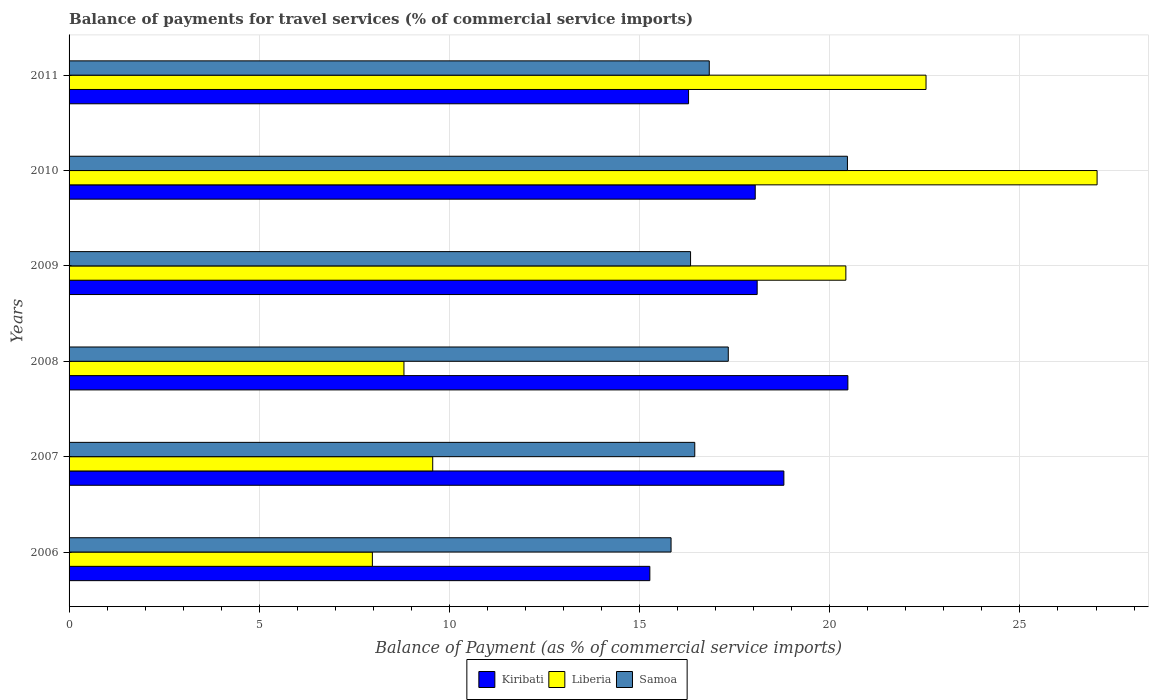Are the number of bars per tick equal to the number of legend labels?
Your response must be concise. Yes. Are the number of bars on each tick of the Y-axis equal?
Give a very brief answer. Yes. How many bars are there on the 5th tick from the bottom?
Make the answer very short. 3. What is the label of the 3rd group of bars from the top?
Provide a short and direct response. 2009. What is the balance of payments for travel services in Liberia in 2007?
Make the answer very short. 9.56. Across all years, what is the maximum balance of payments for travel services in Samoa?
Offer a terse response. 20.46. Across all years, what is the minimum balance of payments for travel services in Kiribati?
Give a very brief answer. 15.27. In which year was the balance of payments for travel services in Liberia maximum?
Your answer should be compact. 2010. What is the total balance of payments for travel services in Samoa in the graph?
Keep it short and to the point. 103.25. What is the difference between the balance of payments for travel services in Kiribati in 2008 and that in 2009?
Give a very brief answer. 2.38. What is the difference between the balance of payments for travel services in Samoa in 2009 and the balance of payments for travel services in Liberia in 2008?
Provide a short and direct response. 7.54. What is the average balance of payments for travel services in Samoa per year?
Ensure brevity in your answer.  17.21. In the year 2008, what is the difference between the balance of payments for travel services in Liberia and balance of payments for travel services in Samoa?
Your answer should be very brief. -8.53. What is the ratio of the balance of payments for travel services in Samoa in 2009 to that in 2010?
Your response must be concise. 0.8. Is the balance of payments for travel services in Kiribati in 2007 less than that in 2010?
Offer a terse response. No. What is the difference between the highest and the second highest balance of payments for travel services in Kiribati?
Ensure brevity in your answer.  1.68. What is the difference between the highest and the lowest balance of payments for travel services in Kiribati?
Provide a short and direct response. 5.21. Is the sum of the balance of payments for travel services in Liberia in 2007 and 2009 greater than the maximum balance of payments for travel services in Kiribati across all years?
Your answer should be very brief. Yes. What does the 2nd bar from the top in 2008 represents?
Ensure brevity in your answer.  Liberia. What does the 2nd bar from the bottom in 2010 represents?
Offer a very short reply. Liberia. How many bars are there?
Provide a succinct answer. 18. Are all the bars in the graph horizontal?
Keep it short and to the point. Yes. How many years are there in the graph?
Your answer should be compact. 6. What is the difference between two consecutive major ticks on the X-axis?
Give a very brief answer. 5. Are the values on the major ticks of X-axis written in scientific E-notation?
Your answer should be compact. No. What is the title of the graph?
Your answer should be very brief. Balance of payments for travel services (% of commercial service imports). Does "Argentina" appear as one of the legend labels in the graph?
Keep it short and to the point. No. What is the label or title of the X-axis?
Provide a short and direct response. Balance of Payment (as % of commercial service imports). What is the Balance of Payment (as % of commercial service imports) in Kiribati in 2006?
Give a very brief answer. 15.27. What is the Balance of Payment (as % of commercial service imports) in Liberia in 2006?
Your response must be concise. 7.97. What is the Balance of Payment (as % of commercial service imports) in Samoa in 2006?
Offer a very short reply. 15.83. What is the Balance of Payment (as % of commercial service imports) of Kiribati in 2007?
Provide a succinct answer. 18.79. What is the Balance of Payment (as % of commercial service imports) of Liberia in 2007?
Offer a terse response. 9.56. What is the Balance of Payment (as % of commercial service imports) in Samoa in 2007?
Ensure brevity in your answer.  16.45. What is the Balance of Payment (as % of commercial service imports) of Kiribati in 2008?
Offer a terse response. 20.48. What is the Balance of Payment (as % of commercial service imports) in Liberia in 2008?
Your response must be concise. 8.8. What is the Balance of Payment (as % of commercial service imports) of Samoa in 2008?
Offer a terse response. 17.33. What is the Balance of Payment (as % of commercial service imports) of Kiribati in 2009?
Offer a very short reply. 18.09. What is the Balance of Payment (as % of commercial service imports) of Liberia in 2009?
Offer a terse response. 20.42. What is the Balance of Payment (as % of commercial service imports) of Samoa in 2009?
Keep it short and to the point. 16.34. What is the Balance of Payment (as % of commercial service imports) of Kiribati in 2010?
Provide a short and direct response. 18.04. What is the Balance of Payment (as % of commercial service imports) of Liberia in 2010?
Give a very brief answer. 27.03. What is the Balance of Payment (as % of commercial service imports) of Samoa in 2010?
Make the answer very short. 20.46. What is the Balance of Payment (as % of commercial service imports) in Kiribati in 2011?
Provide a short and direct response. 16.29. What is the Balance of Payment (as % of commercial service imports) of Liberia in 2011?
Offer a very short reply. 22.53. What is the Balance of Payment (as % of commercial service imports) of Samoa in 2011?
Your answer should be compact. 16.83. Across all years, what is the maximum Balance of Payment (as % of commercial service imports) in Kiribati?
Your answer should be very brief. 20.48. Across all years, what is the maximum Balance of Payment (as % of commercial service imports) in Liberia?
Offer a very short reply. 27.03. Across all years, what is the maximum Balance of Payment (as % of commercial service imports) of Samoa?
Make the answer very short. 20.46. Across all years, what is the minimum Balance of Payment (as % of commercial service imports) in Kiribati?
Ensure brevity in your answer.  15.27. Across all years, what is the minimum Balance of Payment (as % of commercial service imports) of Liberia?
Provide a short and direct response. 7.97. Across all years, what is the minimum Balance of Payment (as % of commercial service imports) in Samoa?
Offer a very short reply. 15.83. What is the total Balance of Payment (as % of commercial service imports) of Kiribati in the graph?
Provide a short and direct response. 106.96. What is the total Balance of Payment (as % of commercial service imports) of Liberia in the graph?
Provide a short and direct response. 96.32. What is the total Balance of Payment (as % of commercial service imports) of Samoa in the graph?
Your response must be concise. 103.25. What is the difference between the Balance of Payment (as % of commercial service imports) of Kiribati in 2006 and that in 2007?
Ensure brevity in your answer.  -3.52. What is the difference between the Balance of Payment (as % of commercial service imports) in Liberia in 2006 and that in 2007?
Ensure brevity in your answer.  -1.59. What is the difference between the Balance of Payment (as % of commercial service imports) of Samoa in 2006 and that in 2007?
Give a very brief answer. -0.62. What is the difference between the Balance of Payment (as % of commercial service imports) of Kiribati in 2006 and that in 2008?
Your answer should be compact. -5.21. What is the difference between the Balance of Payment (as % of commercial service imports) of Liberia in 2006 and that in 2008?
Your response must be concise. -0.83. What is the difference between the Balance of Payment (as % of commercial service imports) in Samoa in 2006 and that in 2008?
Offer a very short reply. -1.5. What is the difference between the Balance of Payment (as % of commercial service imports) of Kiribati in 2006 and that in 2009?
Offer a very short reply. -2.82. What is the difference between the Balance of Payment (as % of commercial service imports) of Liberia in 2006 and that in 2009?
Your response must be concise. -12.45. What is the difference between the Balance of Payment (as % of commercial service imports) in Samoa in 2006 and that in 2009?
Offer a very short reply. -0.51. What is the difference between the Balance of Payment (as % of commercial service imports) of Kiribati in 2006 and that in 2010?
Provide a succinct answer. -2.77. What is the difference between the Balance of Payment (as % of commercial service imports) in Liberia in 2006 and that in 2010?
Provide a succinct answer. -19.05. What is the difference between the Balance of Payment (as % of commercial service imports) of Samoa in 2006 and that in 2010?
Ensure brevity in your answer.  -4.64. What is the difference between the Balance of Payment (as % of commercial service imports) of Kiribati in 2006 and that in 2011?
Offer a terse response. -1.02. What is the difference between the Balance of Payment (as % of commercial service imports) in Liberia in 2006 and that in 2011?
Your answer should be very brief. -14.56. What is the difference between the Balance of Payment (as % of commercial service imports) in Samoa in 2006 and that in 2011?
Your response must be concise. -1. What is the difference between the Balance of Payment (as % of commercial service imports) of Kiribati in 2007 and that in 2008?
Ensure brevity in your answer.  -1.68. What is the difference between the Balance of Payment (as % of commercial service imports) in Liberia in 2007 and that in 2008?
Provide a succinct answer. 0.76. What is the difference between the Balance of Payment (as % of commercial service imports) in Samoa in 2007 and that in 2008?
Provide a succinct answer. -0.88. What is the difference between the Balance of Payment (as % of commercial service imports) of Kiribati in 2007 and that in 2009?
Your response must be concise. 0.7. What is the difference between the Balance of Payment (as % of commercial service imports) of Liberia in 2007 and that in 2009?
Make the answer very short. -10.86. What is the difference between the Balance of Payment (as % of commercial service imports) of Samoa in 2007 and that in 2009?
Your response must be concise. 0.11. What is the difference between the Balance of Payment (as % of commercial service imports) of Kiribati in 2007 and that in 2010?
Offer a very short reply. 0.75. What is the difference between the Balance of Payment (as % of commercial service imports) of Liberia in 2007 and that in 2010?
Provide a short and direct response. -17.47. What is the difference between the Balance of Payment (as % of commercial service imports) in Samoa in 2007 and that in 2010?
Keep it short and to the point. -4.01. What is the difference between the Balance of Payment (as % of commercial service imports) of Kiribati in 2007 and that in 2011?
Offer a very short reply. 2.51. What is the difference between the Balance of Payment (as % of commercial service imports) in Liberia in 2007 and that in 2011?
Offer a terse response. -12.97. What is the difference between the Balance of Payment (as % of commercial service imports) in Samoa in 2007 and that in 2011?
Make the answer very short. -0.38. What is the difference between the Balance of Payment (as % of commercial service imports) of Kiribati in 2008 and that in 2009?
Provide a short and direct response. 2.38. What is the difference between the Balance of Payment (as % of commercial service imports) of Liberia in 2008 and that in 2009?
Offer a very short reply. -11.62. What is the difference between the Balance of Payment (as % of commercial service imports) in Samoa in 2008 and that in 2009?
Provide a succinct answer. 0.99. What is the difference between the Balance of Payment (as % of commercial service imports) in Kiribati in 2008 and that in 2010?
Your answer should be compact. 2.44. What is the difference between the Balance of Payment (as % of commercial service imports) in Liberia in 2008 and that in 2010?
Your answer should be very brief. -18.22. What is the difference between the Balance of Payment (as % of commercial service imports) in Samoa in 2008 and that in 2010?
Offer a very short reply. -3.13. What is the difference between the Balance of Payment (as % of commercial service imports) of Kiribati in 2008 and that in 2011?
Offer a terse response. 4.19. What is the difference between the Balance of Payment (as % of commercial service imports) of Liberia in 2008 and that in 2011?
Ensure brevity in your answer.  -13.73. What is the difference between the Balance of Payment (as % of commercial service imports) in Kiribati in 2009 and that in 2010?
Provide a succinct answer. 0.05. What is the difference between the Balance of Payment (as % of commercial service imports) in Liberia in 2009 and that in 2010?
Your answer should be compact. -6.61. What is the difference between the Balance of Payment (as % of commercial service imports) of Samoa in 2009 and that in 2010?
Ensure brevity in your answer.  -4.12. What is the difference between the Balance of Payment (as % of commercial service imports) of Kiribati in 2009 and that in 2011?
Offer a terse response. 1.8. What is the difference between the Balance of Payment (as % of commercial service imports) in Liberia in 2009 and that in 2011?
Your answer should be compact. -2.11. What is the difference between the Balance of Payment (as % of commercial service imports) of Samoa in 2009 and that in 2011?
Your answer should be very brief. -0.49. What is the difference between the Balance of Payment (as % of commercial service imports) of Kiribati in 2010 and that in 2011?
Make the answer very short. 1.75. What is the difference between the Balance of Payment (as % of commercial service imports) of Liberia in 2010 and that in 2011?
Offer a very short reply. 4.5. What is the difference between the Balance of Payment (as % of commercial service imports) of Samoa in 2010 and that in 2011?
Offer a terse response. 3.63. What is the difference between the Balance of Payment (as % of commercial service imports) in Kiribati in 2006 and the Balance of Payment (as % of commercial service imports) in Liberia in 2007?
Give a very brief answer. 5.71. What is the difference between the Balance of Payment (as % of commercial service imports) of Kiribati in 2006 and the Balance of Payment (as % of commercial service imports) of Samoa in 2007?
Your answer should be compact. -1.18. What is the difference between the Balance of Payment (as % of commercial service imports) in Liberia in 2006 and the Balance of Payment (as % of commercial service imports) in Samoa in 2007?
Make the answer very short. -8.48. What is the difference between the Balance of Payment (as % of commercial service imports) in Kiribati in 2006 and the Balance of Payment (as % of commercial service imports) in Liberia in 2008?
Offer a terse response. 6.46. What is the difference between the Balance of Payment (as % of commercial service imports) in Kiribati in 2006 and the Balance of Payment (as % of commercial service imports) in Samoa in 2008?
Make the answer very short. -2.06. What is the difference between the Balance of Payment (as % of commercial service imports) of Liberia in 2006 and the Balance of Payment (as % of commercial service imports) of Samoa in 2008?
Keep it short and to the point. -9.36. What is the difference between the Balance of Payment (as % of commercial service imports) of Kiribati in 2006 and the Balance of Payment (as % of commercial service imports) of Liberia in 2009?
Make the answer very short. -5.15. What is the difference between the Balance of Payment (as % of commercial service imports) in Kiribati in 2006 and the Balance of Payment (as % of commercial service imports) in Samoa in 2009?
Provide a succinct answer. -1.07. What is the difference between the Balance of Payment (as % of commercial service imports) of Liberia in 2006 and the Balance of Payment (as % of commercial service imports) of Samoa in 2009?
Ensure brevity in your answer.  -8.37. What is the difference between the Balance of Payment (as % of commercial service imports) in Kiribati in 2006 and the Balance of Payment (as % of commercial service imports) in Liberia in 2010?
Offer a very short reply. -11.76. What is the difference between the Balance of Payment (as % of commercial service imports) of Kiribati in 2006 and the Balance of Payment (as % of commercial service imports) of Samoa in 2010?
Your answer should be compact. -5.2. What is the difference between the Balance of Payment (as % of commercial service imports) in Liberia in 2006 and the Balance of Payment (as % of commercial service imports) in Samoa in 2010?
Provide a succinct answer. -12.49. What is the difference between the Balance of Payment (as % of commercial service imports) in Kiribati in 2006 and the Balance of Payment (as % of commercial service imports) in Liberia in 2011?
Provide a succinct answer. -7.26. What is the difference between the Balance of Payment (as % of commercial service imports) in Kiribati in 2006 and the Balance of Payment (as % of commercial service imports) in Samoa in 2011?
Provide a short and direct response. -1.56. What is the difference between the Balance of Payment (as % of commercial service imports) in Liberia in 2006 and the Balance of Payment (as % of commercial service imports) in Samoa in 2011?
Offer a terse response. -8.86. What is the difference between the Balance of Payment (as % of commercial service imports) in Kiribati in 2007 and the Balance of Payment (as % of commercial service imports) in Liberia in 2008?
Ensure brevity in your answer.  9.99. What is the difference between the Balance of Payment (as % of commercial service imports) in Kiribati in 2007 and the Balance of Payment (as % of commercial service imports) in Samoa in 2008?
Provide a short and direct response. 1.46. What is the difference between the Balance of Payment (as % of commercial service imports) of Liberia in 2007 and the Balance of Payment (as % of commercial service imports) of Samoa in 2008?
Ensure brevity in your answer.  -7.77. What is the difference between the Balance of Payment (as % of commercial service imports) of Kiribati in 2007 and the Balance of Payment (as % of commercial service imports) of Liberia in 2009?
Make the answer very short. -1.63. What is the difference between the Balance of Payment (as % of commercial service imports) of Kiribati in 2007 and the Balance of Payment (as % of commercial service imports) of Samoa in 2009?
Offer a terse response. 2.45. What is the difference between the Balance of Payment (as % of commercial service imports) of Liberia in 2007 and the Balance of Payment (as % of commercial service imports) of Samoa in 2009?
Provide a succinct answer. -6.78. What is the difference between the Balance of Payment (as % of commercial service imports) in Kiribati in 2007 and the Balance of Payment (as % of commercial service imports) in Liberia in 2010?
Ensure brevity in your answer.  -8.24. What is the difference between the Balance of Payment (as % of commercial service imports) of Kiribati in 2007 and the Balance of Payment (as % of commercial service imports) of Samoa in 2010?
Your answer should be very brief. -1.67. What is the difference between the Balance of Payment (as % of commercial service imports) in Liberia in 2007 and the Balance of Payment (as % of commercial service imports) in Samoa in 2010?
Offer a terse response. -10.9. What is the difference between the Balance of Payment (as % of commercial service imports) in Kiribati in 2007 and the Balance of Payment (as % of commercial service imports) in Liberia in 2011?
Ensure brevity in your answer.  -3.74. What is the difference between the Balance of Payment (as % of commercial service imports) of Kiribati in 2007 and the Balance of Payment (as % of commercial service imports) of Samoa in 2011?
Your answer should be compact. 1.96. What is the difference between the Balance of Payment (as % of commercial service imports) of Liberia in 2007 and the Balance of Payment (as % of commercial service imports) of Samoa in 2011?
Provide a short and direct response. -7.27. What is the difference between the Balance of Payment (as % of commercial service imports) of Kiribati in 2008 and the Balance of Payment (as % of commercial service imports) of Liberia in 2009?
Keep it short and to the point. 0.05. What is the difference between the Balance of Payment (as % of commercial service imports) in Kiribati in 2008 and the Balance of Payment (as % of commercial service imports) in Samoa in 2009?
Your answer should be compact. 4.14. What is the difference between the Balance of Payment (as % of commercial service imports) of Liberia in 2008 and the Balance of Payment (as % of commercial service imports) of Samoa in 2009?
Make the answer very short. -7.54. What is the difference between the Balance of Payment (as % of commercial service imports) of Kiribati in 2008 and the Balance of Payment (as % of commercial service imports) of Liberia in 2010?
Provide a short and direct response. -6.55. What is the difference between the Balance of Payment (as % of commercial service imports) of Kiribati in 2008 and the Balance of Payment (as % of commercial service imports) of Samoa in 2010?
Your answer should be compact. 0.01. What is the difference between the Balance of Payment (as % of commercial service imports) of Liberia in 2008 and the Balance of Payment (as % of commercial service imports) of Samoa in 2010?
Offer a terse response. -11.66. What is the difference between the Balance of Payment (as % of commercial service imports) of Kiribati in 2008 and the Balance of Payment (as % of commercial service imports) of Liberia in 2011?
Provide a succinct answer. -2.06. What is the difference between the Balance of Payment (as % of commercial service imports) of Kiribati in 2008 and the Balance of Payment (as % of commercial service imports) of Samoa in 2011?
Your response must be concise. 3.64. What is the difference between the Balance of Payment (as % of commercial service imports) of Liberia in 2008 and the Balance of Payment (as % of commercial service imports) of Samoa in 2011?
Your answer should be very brief. -8.03. What is the difference between the Balance of Payment (as % of commercial service imports) of Kiribati in 2009 and the Balance of Payment (as % of commercial service imports) of Liberia in 2010?
Keep it short and to the point. -8.94. What is the difference between the Balance of Payment (as % of commercial service imports) in Kiribati in 2009 and the Balance of Payment (as % of commercial service imports) in Samoa in 2010?
Your answer should be compact. -2.37. What is the difference between the Balance of Payment (as % of commercial service imports) in Liberia in 2009 and the Balance of Payment (as % of commercial service imports) in Samoa in 2010?
Provide a succinct answer. -0.04. What is the difference between the Balance of Payment (as % of commercial service imports) of Kiribati in 2009 and the Balance of Payment (as % of commercial service imports) of Liberia in 2011?
Provide a short and direct response. -4.44. What is the difference between the Balance of Payment (as % of commercial service imports) of Kiribati in 2009 and the Balance of Payment (as % of commercial service imports) of Samoa in 2011?
Make the answer very short. 1.26. What is the difference between the Balance of Payment (as % of commercial service imports) of Liberia in 2009 and the Balance of Payment (as % of commercial service imports) of Samoa in 2011?
Offer a very short reply. 3.59. What is the difference between the Balance of Payment (as % of commercial service imports) in Kiribati in 2010 and the Balance of Payment (as % of commercial service imports) in Liberia in 2011?
Give a very brief answer. -4.49. What is the difference between the Balance of Payment (as % of commercial service imports) in Kiribati in 2010 and the Balance of Payment (as % of commercial service imports) in Samoa in 2011?
Provide a succinct answer. 1.21. What is the difference between the Balance of Payment (as % of commercial service imports) of Liberia in 2010 and the Balance of Payment (as % of commercial service imports) of Samoa in 2011?
Provide a short and direct response. 10.2. What is the average Balance of Payment (as % of commercial service imports) of Kiribati per year?
Your answer should be compact. 17.83. What is the average Balance of Payment (as % of commercial service imports) in Liberia per year?
Provide a succinct answer. 16.05. What is the average Balance of Payment (as % of commercial service imports) in Samoa per year?
Your answer should be compact. 17.21. In the year 2006, what is the difference between the Balance of Payment (as % of commercial service imports) in Kiribati and Balance of Payment (as % of commercial service imports) in Liberia?
Your answer should be compact. 7.3. In the year 2006, what is the difference between the Balance of Payment (as % of commercial service imports) of Kiribati and Balance of Payment (as % of commercial service imports) of Samoa?
Provide a short and direct response. -0.56. In the year 2006, what is the difference between the Balance of Payment (as % of commercial service imports) of Liberia and Balance of Payment (as % of commercial service imports) of Samoa?
Your answer should be compact. -7.85. In the year 2007, what is the difference between the Balance of Payment (as % of commercial service imports) of Kiribati and Balance of Payment (as % of commercial service imports) of Liberia?
Offer a terse response. 9.23. In the year 2007, what is the difference between the Balance of Payment (as % of commercial service imports) in Kiribati and Balance of Payment (as % of commercial service imports) in Samoa?
Your answer should be very brief. 2.34. In the year 2007, what is the difference between the Balance of Payment (as % of commercial service imports) of Liberia and Balance of Payment (as % of commercial service imports) of Samoa?
Make the answer very short. -6.89. In the year 2008, what is the difference between the Balance of Payment (as % of commercial service imports) in Kiribati and Balance of Payment (as % of commercial service imports) in Liberia?
Provide a succinct answer. 11.67. In the year 2008, what is the difference between the Balance of Payment (as % of commercial service imports) of Kiribati and Balance of Payment (as % of commercial service imports) of Samoa?
Your answer should be very brief. 3.14. In the year 2008, what is the difference between the Balance of Payment (as % of commercial service imports) of Liberia and Balance of Payment (as % of commercial service imports) of Samoa?
Offer a very short reply. -8.53. In the year 2009, what is the difference between the Balance of Payment (as % of commercial service imports) of Kiribati and Balance of Payment (as % of commercial service imports) of Liberia?
Provide a succinct answer. -2.33. In the year 2009, what is the difference between the Balance of Payment (as % of commercial service imports) in Kiribati and Balance of Payment (as % of commercial service imports) in Samoa?
Offer a terse response. 1.75. In the year 2009, what is the difference between the Balance of Payment (as % of commercial service imports) of Liberia and Balance of Payment (as % of commercial service imports) of Samoa?
Provide a succinct answer. 4.08. In the year 2010, what is the difference between the Balance of Payment (as % of commercial service imports) of Kiribati and Balance of Payment (as % of commercial service imports) of Liberia?
Offer a very short reply. -8.99. In the year 2010, what is the difference between the Balance of Payment (as % of commercial service imports) of Kiribati and Balance of Payment (as % of commercial service imports) of Samoa?
Your answer should be very brief. -2.42. In the year 2010, what is the difference between the Balance of Payment (as % of commercial service imports) in Liberia and Balance of Payment (as % of commercial service imports) in Samoa?
Your response must be concise. 6.56. In the year 2011, what is the difference between the Balance of Payment (as % of commercial service imports) in Kiribati and Balance of Payment (as % of commercial service imports) in Liberia?
Your response must be concise. -6.24. In the year 2011, what is the difference between the Balance of Payment (as % of commercial service imports) in Kiribati and Balance of Payment (as % of commercial service imports) in Samoa?
Make the answer very short. -0.54. In the year 2011, what is the difference between the Balance of Payment (as % of commercial service imports) in Liberia and Balance of Payment (as % of commercial service imports) in Samoa?
Give a very brief answer. 5.7. What is the ratio of the Balance of Payment (as % of commercial service imports) of Kiribati in 2006 to that in 2007?
Your answer should be compact. 0.81. What is the ratio of the Balance of Payment (as % of commercial service imports) of Liberia in 2006 to that in 2007?
Make the answer very short. 0.83. What is the ratio of the Balance of Payment (as % of commercial service imports) in Samoa in 2006 to that in 2007?
Ensure brevity in your answer.  0.96. What is the ratio of the Balance of Payment (as % of commercial service imports) of Kiribati in 2006 to that in 2008?
Make the answer very short. 0.75. What is the ratio of the Balance of Payment (as % of commercial service imports) of Liberia in 2006 to that in 2008?
Offer a very short reply. 0.91. What is the ratio of the Balance of Payment (as % of commercial service imports) of Samoa in 2006 to that in 2008?
Give a very brief answer. 0.91. What is the ratio of the Balance of Payment (as % of commercial service imports) of Kiribati in 2006 to that in 2009?
Provide a succinct answer. 0.84. What is the ratio of the Balance of Payment (as % of commercial service imports) in Liberia in 2006 to that in 2009?
Keep it short and to the point. 0.39. What is the ratio of the Balance of Payment (as % of commercial service imports) of Samoa in 2006 to that in 2009?
Offer a very short reply. 0.97. What is the ratio of the Balance of Payment (as % of commercial service imports) of Kiribati in 2006 to that in 2010?
Your answer should be compact. 0.85. What is the ratio of the Balance of Payment (as % of commercial service imports) of Liberia in 2006 to that in 2010?
Your response must be concise. 0.29. What is the ratio of the Balance of Payment (as % of commercial service imports) of Samoa in 2006 to that in 2010?
Give a very brief answer. 0.77. What is the ratio of the Balance of Payment (as % of commercial service imports) in Liberia in 2006 to that in 2011?
Keep it short and to the point. 0.35. What is the ratio of the Balance of Payment (as % of commercial service imports) of Samoa in 2006 to that in 2011?
Ensure brevity in your answer.  0.94. What is the ratio of the Balance of Payment (as % of commercial service imports) of Kiribati in 2007 to that in 2008?
Ensure brevity in your answer.  0.92. What is the ratio of the Balance of Payment (as % of commercial service imports) of Liberia in 2007 to that in 2008?
Provide a short and direct response. 1.09. What is the ratio of the Balance of Payment (as % of commercial service imports) in Samoa in 2007 to that in 2008?
Offer a terse response. 0.95. What is the ratio of the Balance of Payment (as % of commercial service imports) in Kiribati in 2007 to that in 2009?
Provide a short and direct response. 1.04. What is the ratio of the Balance of Payment (as % of commercial service imports) of Liberia in 2007 to that in 2009?
Your answer should be compact. 0.47. What is the ratio of the Balance of Payment (as % of commercial service imports) of Samoa in 2007 to that in 2009?
Your answer should be compact. 1.01. What is the ratio of the Balance of Payment (as % of commercial service imports) in Kiribati in 2007 to that in 2010?
Give a very brief answer. 1.04. What is the ratio of the Balance of Payment (as % of commercial service imports) in Liberia in 2007 to that in 2010?
Provide a short and direct response. 0.35. What is the ratio of the Balance of Payment (as % of commercial service imports) of Samoa in 2007 to that in 2010?
Offer a terse response. 0.8. What is the ratio of the Balance of Payment (as % of commercial service imports) in Kiribati in 2007 to that in 2011?
Give a very brief answer. 1.15. What is the ratio of the Balance of Payment (as % of commercial service imports) in Liberia in 2007 to that in 2011?
Offer a very short reply. 0.42. What is the ratio of the Balance of Payment (as % of commercial service imports) of Samoa in 2007 to that in 2011?
Make the answer very short. 0.98. What is the ratio of the Balance of Payment (as % of commercial service imports) in Kiribati in 2008 to that in 2009?
Ensure brevity in your answer.  1.13. What is the ratio of the Balance of Payment (as % of commercial service imports) of Liberia in 2008 to that in 2009?
Your answer should be compact. 0.43. What is the ratio of the Balance of Payment (as % of commercial service imports) in Samoa in 2008 to that in 2009?
Your answer should be very brief. 1.06. What is the ratio of the Balance of Payment (as % of commercial service imports) of Kiribati in 2008 to that in 2010?
Provide a short and direct response. 1.14. What is the ratio of the Balance of Payment (as % of commercial service imports) of Liberia in 2008 to that in 2010?
Offer a terse response. 0.33. What is the ratio of the Balance of Payment (as % of commercial service imports) in Samoa in 2008 to that in 2010?
Offer a terse response. 0.85. What is the ratio of the Balance of Payment (as % of commercial service imports) in Kiribati in 2008 to that in 2011?
Offer a very short reply. 1.26. What is the ratio of the Balance of Payment (as % of commercial service imports) in Liberia in 2008 to that in 2011?
Your answer should be very brief. 0.39. What is the ratio of the Balance of Payment (as % of commercial service imports) in Samoa in 2008 to that in 2011?
Your answer should be compact. 1.03. What is the ratio of the Balance of Payment (as % of commercial service imports) in Liberia in 2009 to that in 2010?
Ensure brevity in your answer.  0.76. What is the ratio of the Balance of Payment (as % of commercial service imports) in Samoa in 2009 to that in 2010?
Make the answer very short. 0.8. What is the ratio of the Balance of Payment (as % of commercial service imports) of Kiribati in 2009 to that in 2011?
Your answer should be compact. 1.11. What is the ratio of the Balance of Payment (as % of commercial service imports) of Liberia in 2009 to that in 2011?
Provide a succinct answer. 0.91. What is the ratio of the Balance of Payment (as % of commercial service imports) of Samoa in 2009 to that in 2011?
Your response must be concise. 0.97. What is the ratio of the Balance of Payment (as % of commercial service imports) in Kiribati in 2010 to that in 2011?
Your answer should be compact. 1.11. What is the ratio of the Balance of Payment (as % of commercial service imports) in Liberia in 2010 to that in 2011?
Offer a very short reply. 1.2. What is the ratio of the Balance of Payment (as % of commercial service imports) in Samoa in 2010 to that in 2011?
Offer a very short reply. 1.22. What is the difference between the highest and the second highest Balance of Payment (as % of commercial service imports) in Kiribati?
Ensure brevity in your answer.  1.68. What is the difference between the highest and the second highest Balance of Payment (as % of commercial service imports) in Liberia?
Your response must be concise. 4.5. What is the difference between the highest and the second highest Balance of Payment (as % of commercial service imports) in Samoa?
Give a very brief answer. 3.13. What is the difference between the highest and the lowest Balance of Payment (as % of commercial service imports) in Kiribati?
Make the answer very short. 5.21. What is the difference between the highest and the lowest Balance of Payment (as % of commercial service imports) in Liberia?
Keep it short and to the point. 19.05. What is the difference between the highest and the lowest Balance of Payment (as % of commercial service imports) in Samoa?
Give a very brief answer. 4.64. 